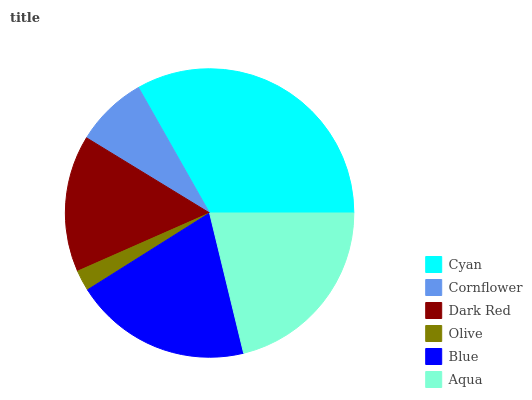Is Olive the minimum?
Answer yes or no. Yes. Is Cyan the maximum?
Answer yes or no. Yes. Is Cornflower the minimum?
Answer yes or no. No. Is Cornflower the maximum?
Answer yes or no. No. Is Cyan greater than Cornflower?
Answer yes or no. Yes. Is Cornflower less than Cyan?
Answer yes or no. Yes. Is Cornflower greater than Cyan?
Answer yes or no. No. Is Cyan less than Cornflower?
Answer yes or no. No. Is Blue the high median?
Answer yes or no. Yes. Is Dark Red the low median?
Answer yes or no. Yes. Is Olive the high median?
Answer yes or no. No. Is Aqua the low median?
Answer yes or no. No. 